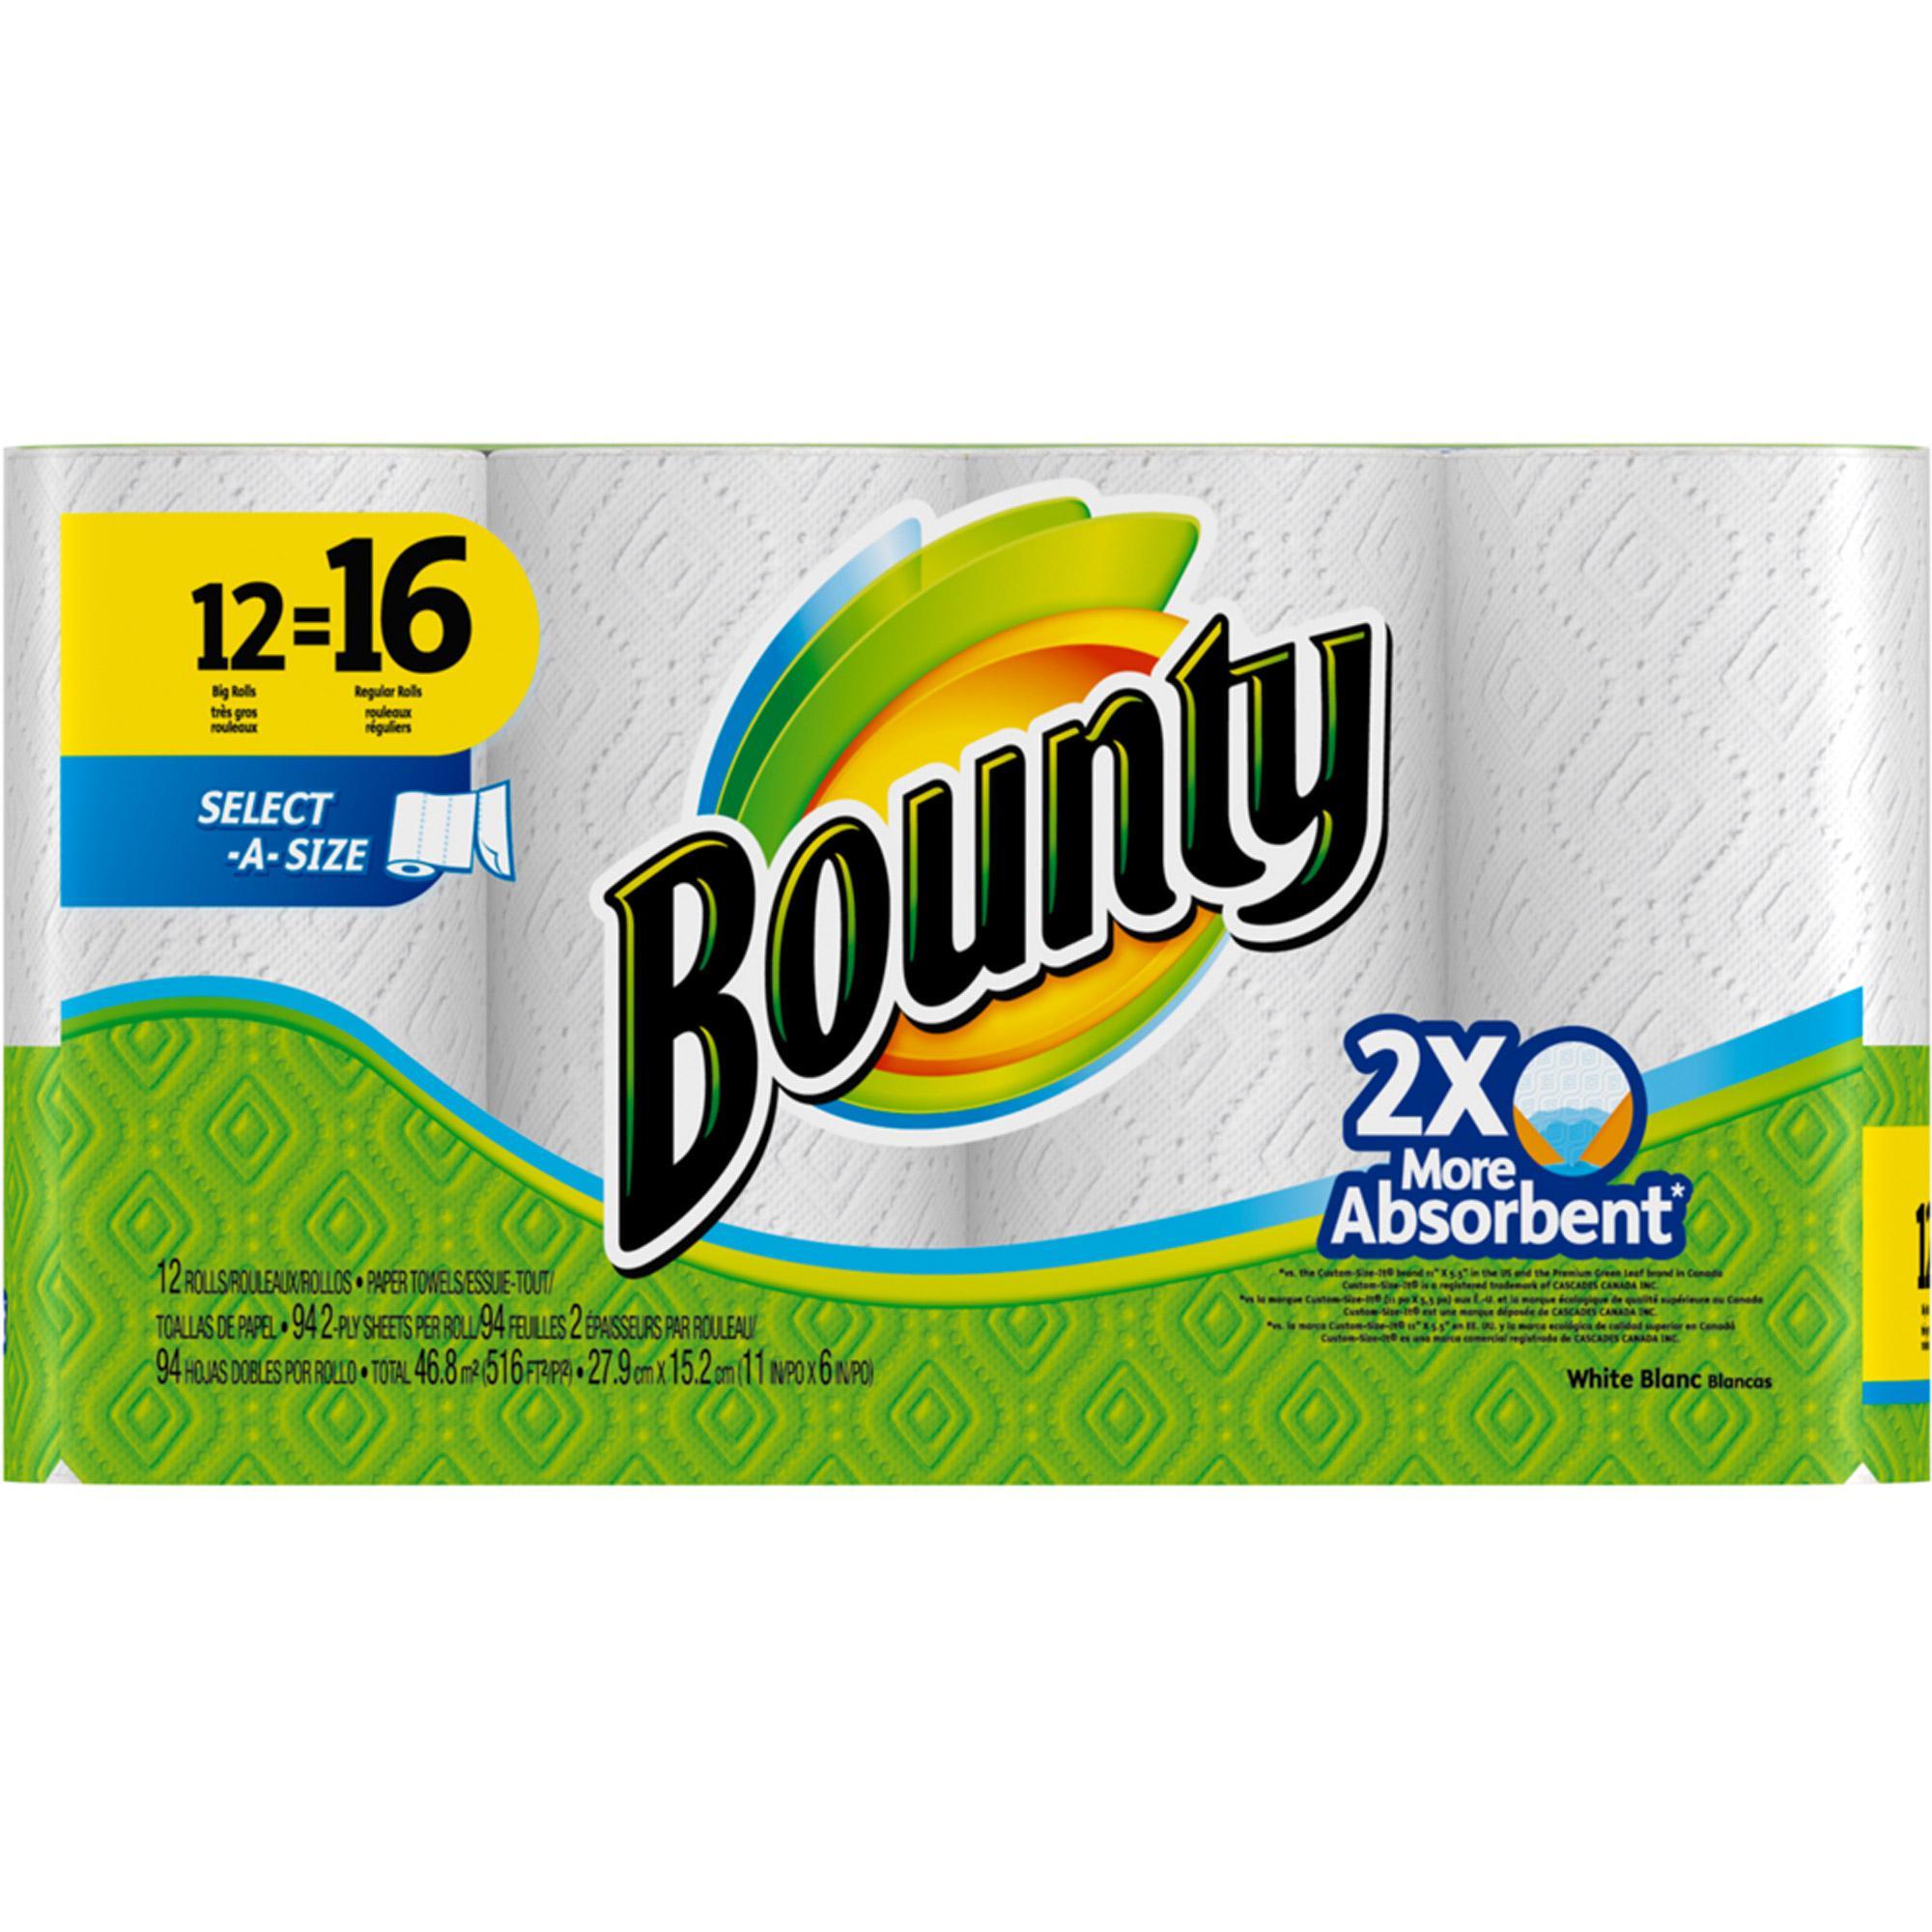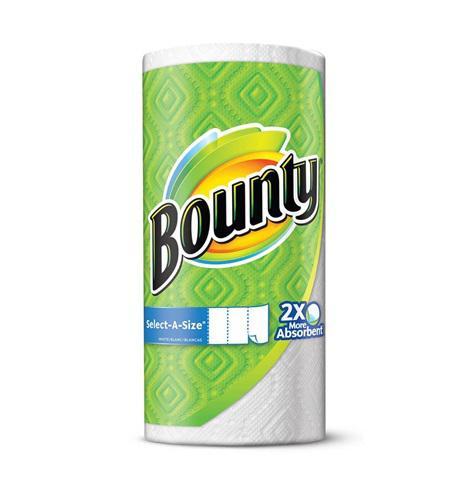The first image is the image on the left, the second image is the image on the right. Analyze the images presented: Is the assertion "There is a single roll of bounty that is in a green place with the bounty label." valid? Answer yes or no. Yes. 